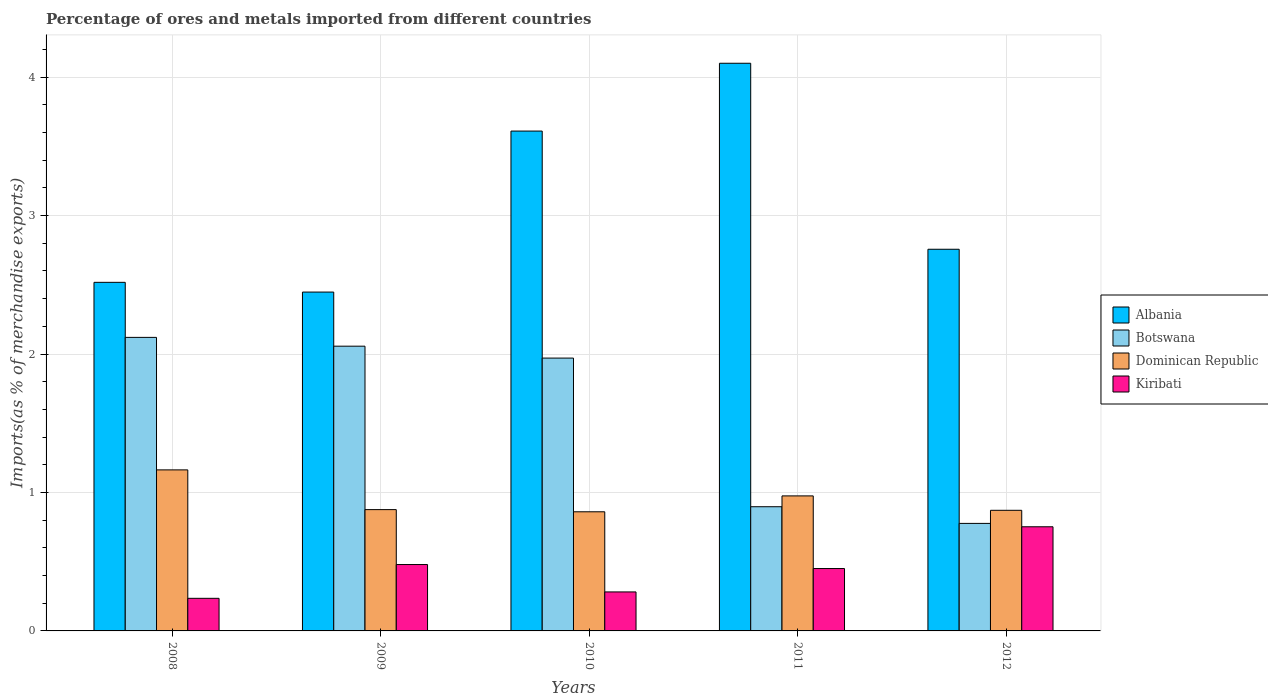How many different coloured bars are there?
Offer a terse response. 4. What is the label of the 4th group of bars from the left?
Provide a short and direct response. 2011. In how many cases, is the number of bars for a given year not equal to the number of legend labels?
Make the answer very short. 0. What is the percentage of imports to different countries in Albania in 2012?
Your answer should be compact. 2.76. Across all years, what is the maximum percentage of imports to different countries in Albania?
Your answer should be very brief. 4.1. Across all years, what is the minimum percentage of imports to different countries in Botswana?
Your answer should be very brief. 0.78. In which year was the percentage of imports to different countries in Botswana maximum?
Offer a terse response. 2008. In which year was the percentage of imports to different countries in Albania minimum?
Your answer should be compact. 2009. What is the total percentage of imports to different countries in Albania in the graph?
Offer a terse response. 15.43. What is the difference between the percentage of imports to different countries in Kiribati in 2009 and that in 2011?
Your answer should be compact. 0.03. What is the difference between the percentage of imports to different countries in Botswana in 2010 and the percentage of imports to different countries in Dominican Republic in 2012?
Ensure brevity in your answer.  1.1. What is the average percentage of imports to different countries in Botswana per year?
Your answer should be compact. 1.56. In the year 2008, what is the difference between the percentage of imports to different countries in Dominican Republic and percentage of imports to different countries in Botswana?
Provide a short and direct response. -0.96. What is the ratio of the percentage of imports to different countries in Albania in 2010 to that in 2011?
Give a very brief answer. 0.88. What is the difference between the highest and the second highest percentage of imports to different countries in Kiribati?
Your answer should be very brief. 0.27. What is the difference between the highest and the lowest percentage of imports to different countries in Albania?
Keep it short and to the point. 1.65. What does the 1st bar from the left in 2011 represents?
Offer a terse response. Albania. What does the 2nd bar from the right in 2012 represents?
Make the answer very short. Dominican Republic. How many bars are there?
Provide a succinct answer. 20. What is the difference between two consecutive major ticks on the Y-axis?
Make the answer very short. 1. Are the values on the major ticks of Y-axis written in scientific E-notation?
Offer a very short reply. No. Does the graph contain any zero values?
Offer a terse response. No. Where does the legend appear in the graph?
Give a very brief answer. Center right. How many legend labels are there?
Keep it short and to the point. 4. What is the title of the graph?
Your response must be concise. Percentage of ores and metals imported from different countries. What is the label or title of the X-axis?
Make the answer very short. Years. What is the label or title of the Y-axis?
Ensure brevity in your answer.  Imports(as % of merchandise exports). What is the Imports(as % of merchandise exports) in Albania in 2008?
Keep it short and to the point. 2.52. What is the Imports(as % of merchandise exports) in Botswana in 2008?
Give a very brief answer. 2.12. What is the Imports(as % of merchandise exports) of Dominican Republic in 2008?
Ensure brevity in your answer.  1.16. What is the Imports(as % of merchandise exports) in Kiribati in 2008?
Provide a short and direct response. 0.24. What is the Imports(as % of merchandise exports) in Albania in 2009?
Ensure brevity in your answer.  2.45. What is the Imports(as % of merchandise exports) of Botswana in 2009?
Offer a very short reply. 2.06. What is the Imports(as % of merchandise exports) of Dominican Republic in 2009?
Provide a succinct answer. 0.88. What is the Imports(as % of merchandise exports) in Kiribati in 2009?
Give a very brief answer. 0.48. What is the Imports(as % of merchandise exports) in Albania in 2010?
Ensure brevity in your answer.  3.61. What is the Imports(as % of merchandise exports) of Botswana in 2010?
Ensure brevity in your answer.  1.97. What is the Imports(as % of merchandise exports) in Dominican Republic in 2010?
Keep it short and to the point. 0.86. What is the Imports(as % of merchandise exports) in Kiribati in 2010?
Offer a very short reply. 0.28. What is the Imports(as % of merchandise exports) of Albania in 2011?
Provide a succinct answer. 4.1. What is the Imports(as % of merchandise exports) of Botswana in 2011?
Offer a terse response. 0.9. What is the Imports(as % of merchandise exports) of Dominican Republic in 2011?
Your answer should be very brief. 0.98. What is the Imports(as % of merchandise exports) of Kiribati in 2011?
Provide a short and direct response. 0.45. What is the Imports(as % of merchandise exports) in Albania in 2012?
Your response must be concise. 2.76. What is the Imports(as % of merchandise exports) in Botswana in 2012?
Provide a succinct answer. 0.78. What is the Imports(as % of merchandise exports) of Dominican Republic in 2012?
Give a very brief answer. 0.87. What is the Imports(as % of merchandise exports) of Kiribati in 2012?
Your answer should be very brief. 0.75. Across all years, what is the maximum Imports(as % of merchandise exports) in Albania?
Give a very brief answer. 4.1. Across all years, what is the maximum Imports(as % of merchandise exports) of Botswana?
Offer a very short reply. 2.12. Across all years, what is the maximum Imports(as % of merchandise exports) of Dominican Republic?
Give a very brief answer. 1.16. Across all years, what is the maximum Imports(as % of merchandise exports) in Kiribati?
Make the answer very short. 0.75. Across all years, what is the minimum Imports(as % of merchandise exports) of Albania?
Make the answer very short. 2.45. Across all years, what is the minimum Imports(as % of merchandise exports) in Botswana?
Offer a terse response. 0.78. Across all years, what is the minimum Imports(as % of merchandise exports) in Dominican Republic?
Provide a short and direct response. 0.86. Across all years, what is the minimum Imports(as % of merchandise exports) in Kiribati?
Ensure brevity in your answer.  0.24. What is the total Imports(as % of merchandise exports) in Albania in the graph?
Keep it short and to the point. 15.43. What is the total Imports(as % of merchandise exports) in Botswana in the graph?
Your answer should be compact. 7.82. What is the total Imports(as % of merchandise exports) of Dominican Republic in the graph?
Your answer should be very brief. 4.75. What is the total Imports(as % of merchandise exports) in Kiribati in the graph?
Offer a terse response. 2.2. What is the difference between the Imports(as % of merchandise exports) of Albania in 2008 and that in 2009?
Your answer should be compact. 0.07. What is the difference between the Imports(as % of merchandise exports) of Botswana in 2008 and that in 2009?
Provide a succinct answer. 0.06. What is the difference between the Imports(as % of merchandise exports) of Dominican Republic in 2008 and that in 2009?
Your response must be concise. 0.29. What is the difference between the Imports(as % of merchandise exports) in Kiribati in 2008 and that in 2009?
Provide a succinct answer. -0.24. What is the difference between the Imports(as % of merchandise exports) of Albania in 2008 and that in 2010?
Your answer should be compact. -1.09. What is the difference between the Imports(as % of merchandise exports) in Botswana in 2008 and that in 2010?
Your answer should be compact. 0.15. What is the difference between the Imports(as % of merchandise exports) in Dominican Republic in 2008 and that in 2010?
Your answer should be compact. 0.3. What is the difference between the Imports(as % of merchandise exports) of Kiribati in 2008 and that in 2010?
Keep it short and to the point. -0.05. What is the difference between the Imports(as % of merchandise exports) of Albania in 2008 and that in 2011?
Give a very brief answer. -1.58. What is the difference between the Imports(as % of merchandise exports) in Botswana in 2008 and that in 2011?
Your answer should be compact. 1.22. What is the difference between the Imports(as % of merchandise exports) in Dominican Republic in 2008 and that in 2011?
Offer a very short reply. 0.19. What is the difference between the Imports(as % of merchandise exports) in Kiribati in 2008 and that in 2011?
Provide a short and direct response. -0.22. What is the difference between the Imports(as % of merchandise exports) of Albania in 2008 and that in 2012?
Your answer should be compact. -0.24. What is the difference between the Imports(as % of merchandise exports) of Botswana in 2008 and that in 2012?
Your response must be concise. 1.34. What is the difference between the Imports(as % of merchandise exports) of Dominican Republic in 2008 and that in 2012?
Give a very brief answer. 0.29. What is the difference between the Imports(as % of merchandise exports) of Kiribati in 2008 and that in 2012?
Make the answer very short. -0.52. What is the difference between the Imports(as % of merchandise exports) of Albania in 2009 and that in 2010?
Make the answer very short. -1.16. What is the difference between the Imports(as % of merchandise exports) in Botswana in 2009 and that in 2010?
Offer a very short reply. 0.09. What is the difference between the Imports(as % of merchandise exports) of Dominican Republic in 2009 and that in 2010?
Your answer should be very brief. 0.02. What is the difference between the Imports(as % of merchandise exports) of Kiribati in 2009 and that in 2010?
Keep it short and to the point. 0.2. What is the difference between the Imports(as % of merchandise exports) of Albania in 2009 and that in 2011?
Give a very brief answer. -1.65. What is the difference between the Imports(as % of merchandise exports) in Botswana in 2009 and that in 2011?
Ensure brevity in your answer.  1.16. What is the difference between the Imports(as % of merchandise exports) of Dominican Republic in 2009 and that in 2011?
Your answer should be compact. -0.1. What is the difference between the Imports(as % of merchandise exports) in Kiribati in 2009 and that in 2011?
Give a very brief answer. 0.03. What is the difference between the Imports(as % of merchandise exports) of Albania in 2009 and that in 2012?
Offer a terse response. -0.31. What is the difference between the Imports(as % of merchandise exports) of Botswana in 2009 and that in 2012?
Provide a succinct answer. 1.28. What is the difference between the Imports(as % of merchandise exports) of Dominican Republic in 2009 and that in 2012?
Your response must be concise. 0. What is the difference between the Imports(as % of merchandise exports) in Kiribati in 2009 and that in 2012?
Make the answer very short. -0.27. What is the difference between the Imports(as % of merchandise exports) of Albania in 2010 and that in 2011?
Your answer should be very brief. -0.49. What is the difference between the Imports(as % of merchandise exports) in Botswana in 2010 and that in 2011?
Your answer should be very brief. 1.07. What is the difference between the Imports(as % of merchandise exports) of Dominican Republic in 2010 and that in 2011?
Keep it short and to the point. -0.11. What is the difference between the Imports(as % of merchandise exports) in Kiribati in 2010 and that in 2011?
Make the answer very short. -0.17. What is the difference between the Imports(as % of merchandise exports) in Albania in 2010 and that in 2012?
Ensure brevity in your answer.  0.85. What is the difference between the Imports(as % of merchandise exports) in Botswana in 2010 and that in 2012?
Your answer should be compact. 1.19. What is the difference between the Imports(as % of merchandise exports) of Dominican Republic in 2010 and that in 2012?
Your answer should be compact. -0.01. What is the difference between the Imports(as % of merchandise exports) of Kiribati in 2010 and that in 2012?
Your response must be concise. -0.47. What is the difference between the Imports(as % of merchandise exports) in Albania in 2011 and that in 2012?
Keep it short and to the point. 1.34. What is the difference between the Imports(as % of merchandise exports) in Botswana in 2011 and that in 2012?
Ensure brevity in your answer.  0.12. What is the difference between the Imports(as % of merchandise exports) of Dominican Republic in 2011 and that in 2012?
Your response must be concise. 0.1. What is the difference between the Imports(as % of merchandise exports) of Kiribati in 2011 and that in 2012?
Your answer should be compact. -0.3. What is the difference between the Imports(as % of merchandise exports) of Albania in 2008 and the Imports(as % of merchandise exports) of Botswana in 2009?
Make the answer very short. 0.46. What is the difference between the Imports(as % of merchandise exports) in Albania in 2008 and the Imports(as % of merchandise exports) in Dominican Republic in 2009?
Ensure brevity in your answer.  1.64. What is the difference between the Imports(as % of merchandise exports) in Albania in 2008 and the Imports(as % of merchandise exports) in Kiribati in 2009?
Give a very brief answer. 2.04. What is the difference between the Imports(as % of merchandise exports) in Botswana in 2008 and the Imports(as % of merchandise exports) in Dominican Republic in 2009?
Your response must be concise. 1.24. What is the difference between the Imports(as % of merchandise exports) of Botswana in 2008 and the Imports(as % of merchandise exports) of Kiribati in 2009?
Your answer should be very brief. 1.64. What is the difference between the Imports(as % of merchandise exports) of Dominican Republic in 2008 and the Imports(as % of merchandise exports) of Kiribati in 2009?
Give a very brief answer. 0.68. What is the difference between the Imports(as % of merchandise exports) of Albania in 2008 and the Imports(as % of merchandise exports) of Botswana in 2010?
Give a very brief answer. 0.55. What is the difference between the Imports(as % of merchandise exports) in Albania in 2008 and the Imports(as % of merchandise exports) in Dominican Republic in 2010?
Offer a very short reply. 1.66. What is the difference between the Imports(as % of merchandise exports) of Albania in 2008 and the Imports(as % of merchandise exports) of Kiribati in 2010?
Keep it short and to the point. 2.24. What is the difference between the Imports(as % of merchandise exports) of Botswana in 2008 and the Imports(as % of merchandise exports) of Dominican Republic in 2010?
Offer a very short reply. 1.26. What is the difference between the Imports(as % of merchandise exports) of Botswana in 2008 and the Imports(as % of merchandise exports) of Kiribati in 2010?
Provide a succinct answer. 1.84. What is the difference between the Imports(as % of merchandise exports) in Dominican Republic in 2008 and the Imports(as % of merchandise exports) in Kiribati in 2010?
Make the answer very short. 0.88. What is the difference between the Imports(as % of merchandise exports) in Albania in 2008 and the Imports(as % of merchandise exports) in Botswana in 2011?
Make the answer very short. 1.62. What is the difference between the Imports(as % of merchandise exports) of Albania in 2008 and the Imports(as % of merchandise exports) of Dominican Republic in 2011?
Give a very brief answer. 1.54. What is the difference between the Imports(as % of merchandise exports) in Albania in 2008 and the Imports(as % of merchandise exports) in Kiribati in 2011?
Ensure brevity in your answer.  2.07. What is the difference between the Imports(as % of merchandise exports) in Botswana in 2008 and the Imports(as % of merchandise exports) in Dominican Republic in 2011?
Offer a very short reply. 1.15. What is the difference between the Imports(as % of merchandise exports) in Botswana in 2008 and the Imports(as % of merchandise exports) in Kiribati in 2011?
Make the answer very short. 1.67. What is the difference between the Imports(as % of merchandise exports) in Dominican Republic in 2008 and the Imports(as % of merchandise exports) in Kiribati in 2011?
Ensure brevity in your answer.  0.71. What is the difference between the Imports(as % of merchandise exports) in Albania in 2008 and the Imports(as % of merchandise exports) in Botswana in 2012?
Make the answer very short. 1.74. What is the difference between the Imports(as % of merchandise exports) of Albania in 2008 and the Imports(as % of merchandise exports) of Dominican Republic in 2012?
Your response must be concise. 1.65. What is the difference between the Imports(as % of merchandise exports) of Albania in 2008 and the Imports(as % of merchandise exports) of Kiribati in 2012?
Provide a succinct answer. 1.77. What is the difference between the Imports(as % of merchandise exports) of Botswana in 2008 and the Imports(as % of merchandise exports) of Dominican Republic in 2012?
Give a very brief answer. 1.25. What is the difference between the Imports(as % of merchandise exports) of Botswana in 2008 and the Imports(as % of merchandise exports) of Kiribati in 2012?
Keep it short and to the point. 1.37. What is the difference between the Imports(as % of merchandise exports) of Dominican Republic in 2008 and the Imports(as % of merchandise exports) of Kiribati in 2012?
Offer a terse response. 0.41. What is the difference between the Imports(as % of merchandise exports) of Albania in 2009 and the Imports(as % of merchandise exports) of Botswana in 2010?
Your answer should be very brief. 0.48. What is the difference between the Imports(as % of merchandise exports) in Albania in 2009 and the Imports(as % of merchandise exports) in Dominican Republic in 2010?
Ensure brevity in your answer.  1.59. What is the difference between the Imports(as % of merchandise exports) of Albania in 2009 and the Imports(as % of merchandise exports) of Kiribati in 2010?
Your response must be concise. 2.17. What is the difference between the Imports(as % of merchandise exports) of Botswana in 2009 and the Imports(as % of merchandise exports) of Dominican Republic in 2010?
Provide a succinct answer. 1.2. What is the difference between the Imports(as % of merchandise exports) in Botswana in 2009 and the Imports(as % of merchandise exports) in Kiribati in 2010?
Your response must be concise. 1.78. What is the difference between the Imports(as % of merchandise exports) in Dominican Republic in 2009 and the Imports(as % of merchandise exports) in Kiribati in 2010?
Ensure brevity in your answer.  0.59. What is the difference between the Imports(as % of merchandise exports) of Albania in 2009 and the Imports(as % of merchandise exports) of Botswana in 2011?
Provide a succinct answer. 1.55. What is the difference between the Imports(as % of merchandise exports) in Albania in 2009 and the Imports(as % of merchandise exports) in Dominican Republic in 2011?
Give a very brief answer. 1.47. What is the difference between the Imports(as % of merchandise exports) of Albania in 2009 and the Imports(as % of merchandise exports) of Kiribati in 2011?
Your answer should be very brief. 2. What is the difference between the Imports(as % of merchandise exports) of Botswana in 2009 and the Imports(as % of merchandise exports) of Dominican Republic in 2011?
Your answer should be compact. 1.08. What is the difference between the Imports(as % of merchandise exports) of Botswana in 2009 and the Imports(as % of merchandise exports) of Kiribati in 2011?
Offer a terse response. 1.61. What is the difference between the Imports(as % of merchandise exports) in Dominican Republic in 2009 and the Imports(as % of merchandise exports) in Kiribati in 2011?
Make the answer very short. 0.43. What is the difference between the Imports(as % of merchandise exports) of Albania in 2009 and the Imports(as % of merchandise exports) of Botswana in 2012?
Provide a succinct answer. 1.67. What is the difference between the Imports(as % of merchandise exports) of Albania in 2009 and the Imports(as % of merchandise exports) of Dominican Republic in 2012?
Provide a short and direct response. 1.58. What is the difference between the Imports(as % of merchandise exports) of Albania in 2009 and the Imports(as % of merchandise exports) of Kiribati in 2012?
Give a very brief answer. 1.7. What is the difference between the Imports(as % of merchandise exports) of Botswana in 2009 and the Imports(as % of merchandise exports) of Dominican Republic in 2012?
Provide a succinct answer. 1.19. What is the difference between the Imports(as % of merchandise exports) in Botswana in 2009 and the Imports(as % of merchandise exports) in Kiribati in 2012?
Provide a short and direct response. 1.3. What is the difference between the Imports(as % of merchandise exports) of Dominican Republic in 2009 and the Imports(as % of merchandise exports) of Kiribati in 2012?
Your answer should be compact. 0.12. What is the difference between the Imports(as % of merchandise exports) in Albania in 2010 and the Imports(as % of merchandise exports) in Botswana in 2011?
Make the answer very short. 2.71. What is the difference between the Imports(as % of merchandise exports) of Albania in 2010 and the Imports(as % of merchandise exports) of Dominican Republic in 2011?
Offer a terse response. 2.64. What is the difference between the Imports(as % of merchandise exports) in Albania in 2010 and the Imports(as % of merchandise exports) in Kiribati in 2011?
Make the answer very short. 3.16. What is the difference between the Imports(as % of merchandise exports) in Botswana in 2010 and the Imports(as % of merchandise exports) in Dominican Republic in 2011?
Your answer should be compact. 1. What is the difference between the Imports(as % of merchandise exports) of Botswana in 2010 and the Imports(as % of merchandise exports) of Kiribati in 2011?
Your answer should be compact. 1.52. What is the difference between the Imports(as % of merchandise exports) in Dominican Republic in 2010 and the Imports(as % of merchandise exports) in Kiribati in 2011?
Ensure brevity in your answer.  0.41. What is the difference between the Imports(as % of merchandise exports) of Albania in 2010 and the Imports(as % of merchandise exports) of Botswana in 2012?
Provide a short and direct response. 2.83. What is the difference between the Imports(as % of merchandise exports) in Albania in 2010 and the Imports(as % of merchandise exports) in Dominican Republic in 2012?
Give a very brief answer. 2.74. What is the difference between the Imports(as % of merchandise exports) in Albania in 2010 and the Imports(as % of merchandise exports) in Kiribati in 2012?
Ensure brevity in your answer.  2.86. What is the difference between the Imports(as % of merchandise exports) in Botswana in 2010 and the Imports(as % of merchandise exports) in Dominican Republic in 2012?
Your response must be concise. 1.1. What is the difference between the Imports(as % of merchandise exports) of Botswana in 2010 and the Imports(as % of merchandise exports) of Kiribati in 2012?
Make the answer very short. 1.22. What is the difference between the Imports(as % of merchandise exports) in Dominican Republic in 2010 and the Imports(as % of merchandise exports) in Kiribati in 2012?
Provide a short and direct response. 0.11. What is the difference between the Imports(as % of merchandise exports) in Albania in 2011 and the Imports(as % of merchandise exports) in Botswana in 2012?
Make the answer very short. 3.32. What is the difference between the Imports(as % of merchandise exports) of Albania in 2011 and the Imports(as % of merchandise exports) of Dominican Republic in 2012?
Your answer should be compact. 3.23. What is the difference between the Imports(as % of merchandise exports) in Albania in 2011 and the Imports(as % of merchandise exports) in Kiribati in 2012?
Provide a short and direct response. 3.35. What is the difference between the Imports(as % of merchandise exports) of Botswana in 2011 and the Imports(as % of merchandise exports) of Dominican Republic in 2012?
Offer a terse response. 0.03. What is the difference between the Imports(as % of merchandise exports) in Botswana in 2011 and the Imports(as % of merchandise exports) in Kiribati in 2012?
Give a very brief answer. 0.14. What is the difference between the Imports(as % of merchandise exports) in Dominican Republic in 2011 and the Imports(as % of merchandise exports) in Kiribati in 2012?
Keep it short and to the point. 0.22. What is the average Imports(as % of merchandise exports) in Albania per year?
Make the answer very short. 3.09. What is the average Imports(as % of merchandise exports) in Botswana per year?
Your answer should be very brief. 1.56. What is the average Imports(as % of merchandise exports) in Dominican Republic per year?
Offer a very short reply. 0.95. What is the average Imports(as % of merchandise exports) of Kiribati per year?
Your answer should be compact. 0.44. In the year 2008, what is the difference between the Imports(as % of merchandise exports) of Albania and Imports(as % of merchandise exports) of Botswana?
Give a very brief answer. 0.4. In the year 2008, what is the difference between the Imports(as % of merchandise exports) in Albania and Imports(as % of merchandise exports) in Dominican Republic?
Your answer should be compact. 1.35. In the year 2008, what is the difference between the Imports(as % of merchandise exports) in Albania and Imports(as % of merchandise exports) in Kiribati?
Provide a succinct answer. 2.28. In the year 2008, what is the difference between the Imports(as % of merchandise exports) of Botswana and Imports(as % of merchandise exports) of Dominican Republic?
Ensure brevity in your answer.  0.96. In the year 2008, what is the difference between the Imports(as % of merchandise exports) of Botswana and Imports(as % of merchandise exports) of Kiribati?
Provide a succinct answer. 1.88. In the year 2008, what is the difference between the Imports(as % of merchandise exports) of Dominican Republic and Imports(as % of merchandise exports) of Kiribati?
Your answer should be very brief. 0.93. In the year 2009, what is the difference between the Imports(as % of merchandise exports) of Albania and Imports(as % of merchandise exports) of Botswana?
Your response must be concise. 0.39. In the year 2009, what is the difference between the Imports(as % of merchandise exports) of Albania and Imports(as % of merchandise exports) of Dominican Republic?
Provide a succinct answer. 1.57. In the year 2009, what is the difference between the Imports(as % of merchandise exports) in Albania and Imports(as % of merchandise exports) in Kiribati?
Give a very brief answer. 1.97. In the year 2009, what is the difference between the Imports(as % of merchandise exports) of Botswana and Imports(as % of merchandise exports) of Dominican Republic?
Your answer should be compact. 1.18. In the year 2009, what is the difference between the Imports(as % of merchandise exports) in Botswana and Imports(as % of merchandise exports) in Kiribati?
Your response must be concise. 1.58. In the year 2009, what is the difference between the Imports(as % of merchandise exports) in Dominican Republic and Imports(as % of merchandise exports) in Kiribati?
Make the answer very short. 0.4. In the year 2010, what is the difference between the Imports(as % of merchandise exports) in Albania and Imports(as % of merchandise exports) in Botswana?
Offer a very short reply. 1.64. In the year 2010, what is the difference between the Imports(as % of merchandise exports) in Albania and Imports(as % of merchandise exports) in Dominican Republic?
Your answer should be very brief. 2.75. In the year 2010, what is the difference between the Imports(as % of merchandise exports) of Albania and Imports(as % of merchandise exports) of Kiribati?
Your response must be concise. 3.33. In the year 2010, what is the difference between the Imports(as % of merchandise exports) in Botswana and Imports(as % of merchandise exports) in Dominican Republic?
Your answer should be compact. 1.11. In the year 2010, what is the difference between the Imports(as % of merchandise exports) of Botswana and Imports(as % of merchandise exports) of Kiribati?
Your response must be concise. 1.69. In the year 2010, what is the difference between the Imports(as % of merchandise exports) of Dominican Republic and Imports(as % of merchandise exports) of Kiribati?
Give a very brief answer. 0.58. In the year 2011, what is the difference between the Imports(as % of merchandise exports) of Albania and Imports(as % of merchandise exports) of Botswana?
Your answer should be compact. 3.2. In the year 2011, what is the difference between the Imports(as % of merchandise exports) in Albania and Imports(as % of merchandise exports) in Dominican Republic?
Offer a terse response. 3.13. In the year 2011, what is the difference between the Imports(as % of merchandise exports) in Albania and Imports(as % of merchandise exports) in Kiribati?
Offer a very short reply. 3.65. In the year 2011, what is the difference between the Imports(as % of merchandise exports) of Botswana and Imports(as % of merchandise exports) of Dominican Republic?
Make the answer very short. -0.08. In the year 2011, what is the difference between the Imports(as % of merchandise exports) of Botswana and Imports(as % of merchandise exports) of Kiribati?
Provide a succinct answer. 0.45. In the year 2011, what is the difference between the Imports(as % of merchandise exports) in Dominican Republic and Imports(as % of merchandise exports) in Kiribati?
Your answer should be very brief. 0.52. In the year 2012, what is the difference between the Imports(as % of merchandise exports) of Albania and Imports(as % of merchandise exports) of Botswana?
Your answer should be compact. 1.98. In the year 2012, what is the difference between the Imports(as % of merchandise exports) in Albania and Imports(as % of merchandise exports) in Dominican Republic?
Your answer should be compact. 1.89. In the year 2012, what is the difference between the Imports(as % of merchandise exports) in Albania and Imports(as % of merchandise exports) in Kiribati?
Offer a terse response. 2. In the year 2012, what is the difference between the Imports(as % of merchandise exports) in Botswana and Imports(as % of merchandise exports) in Dominican Republic?
Offer a terse response. -0.09. In the year 2012, what is the difference between the Imports(as % of merchandise exports) in Botswana and Imports(as % of merchandise exports) in Kiribati?
Ensure brevity in your answer.  0.02. In the year 2012, what is the difference between the Imports(as % of merchandise exports) in Dominican Republic and Imports(as % of merchandise exports) in Kiribati?
Your response must be concise. 0.12. What is the ratio of the Imports(as % of merchandise exports) in Albania in 2008 to that in 2009?
Your answer should be very brief. 1.03. What is the ratio of the Imports(as % of merchandise exports) in Botswana in 2008 to that in 2009?
Your answer should be very brief. 1.03. What is the ratio of the Imports(as % of merchandise exports) in Dominican Republic in 2008 to that in 2009?
Ensure brevity in your answer.  1.33. What is the ratio of the Imports(as % of merchandise exports) of Kiribati in 2008 to that in 2009?
Offer a terse response. 0.49. What is the ratio of the Imports(as % of merchandise exports) in Albania in 2008 to that in 2010?
Offer a very short reply. 0.7. What is the ratio of the Imports(as % of merchandise exports) in Botswana in 2008 to that in 2010?
Make the answer very short. 1.08. What is the ratio of the Imports(as % of merchandise exports) in Dominican Republic in 2008 to that in 2010?
Make the answer very short. 1.35. What is the ratio of the Imports(as % of merchandise exports) in Kiribati in 2008 to that in 2010?
Offer a terse response. 0.84. What is the ratio of the Imports(as % of merchandise exports) in Albania in 2008 to that in 2011?
Your answer should be very brief. 0.61. What is the ratio of the Imports(as % of merchandise exports) of Botswana in 2008 to that in 2011?
Provide a succinct answer. 2.36. What is the ratio of the Imports(as % of merchandise exports) of Dominican Republic in 2008 to that in 2011?
Make the answer very short. 1.19. What is the ratio of the Imports(as % of merchandise exports) of Kiribati in 2008 to that in 2011?
Offer a very short reply. 0.52. What is the ratio of the Imports(as % of merchandise exports) of Albania in 2008 to that in 2012?
Provide a succinct answer. 0.91. What is the ratio of the Imports(as % of merchandise exports) in Botswana in 2008 to that in 2012?
Make the answer very short. 2.73. What is the ratio of the Imports(as % of merchandise exports) of Dominican Republic in 2008 to that in 2012?
Keep it short and to the point. 1.34. What is the ratio of the Imports(as % of merchandise exports) of Kiribati in 2008 to that in 2012?
Provide a short and direct response. 0.31. What is the ratio of the Imports(as % of merchandise exports) of Albania in 2009 to that in 2010?
Offer a terse response. 0.68. What is the ratio of the Imports(as % of merchandise exports) in Botswana in 2009 to that in 2010?
Your answer should be compact. 1.04. What is the ratio of the Imports(as % of merchandise exports) of Dominican Republic in 2009 to that in 2010?
Keep it short and to the point. 1.02. What is the ratio of the Imports(as % of merchandise exports) of Kiribati in 2009 to that in 2010?
Your answer should be very brief. 1.7. What is the ratio of the Imports(as % of merchandise exports) in Albania in 2009 to that in 2011?
Provide a succinct answer. 0.6. What is the ratio of the Imports(as % of merchandise exports) in Botswana in 2009 to that in 2011?
Keep it short and to the point. 2.29. What is the ratio of the Imports(as % of merchandise exports) of Dominican Republic in 2009 to that in 2011?
Provide a succinct answer. 0.9. What is the ratio of the Imports(as % of merchandise exports) in Kiribati in 2009 to that in 2011?
Give a very brief answer. 1.06. What is the ratio of the Imports(as % of merchandise exports) in Albania in 2009 to that in 2012?
Your answer should be compact. 0.89. What is the ratio of the Imports(as % of merchandise exports) of Botswana in 2009 to that in 2012?
Offer a terse response. 2.65. What is the ratio of the Imports(as % of merchandise exports) of Kiribati in 2009 to that in 2012?
Offer a terse response. 0.64. What is the ratio of the Imports(as % of merchandise exports) in Albania in 2010 to that in 2011?
Provide a succinct answer. 0.88. What is the ratio of the Imports(as % of merchandise exports) in Botswana in 2010 to that in 2011?
Provide a short and direct response. 2.2. What is the ratio of the Imports(as % of merchandise exports) in Dominican Republic in 2010 to that in 2011?
Your answer should be very brief. 0.88. What is the ratio of the Imports(as % of merchandise exports) in Kiribati in 2010 to that in 2011?
Offer a very short reply. 0.63. What is the ratio of the Imports(as % of merchandise exports) of Albania in 2010 to that in 2012?
Your response must be concise. 1.31. What is the ratio of the Imports(as % of merchandise exports) in Botswana in 2010 to that in 2012?
Your response must be concise. 2.54. What is the ratio of the Imports(as % of merchandise exports) in Dominican Republic in 2010 to that in 2012?
Your answer should be compact. 0.99. What is the ratio of the Imports(as % of merchandise exports) of Kiribati in 2010 to that in 2012?
Make the answer very short. 0.37. What is the ratio of the Imports(as % of merchandise exports) of Albania in 2011 to that in 2012?
Your answer should be very brief. 1.49. What is the ratio of the Imports(as % of merchandise exports) in Botswana in 2011 to that in 2012?
Your response must be concise. 1.15. What is the ratio of the Imports(as % of merchandise exports) in Dominican Republic in 2011 to that in 2012?
Your answer should be very brief. 1.12. What is the ratio of the Imports(as % of merchandise exports) in Kiribati in 2011 to that in 2012?
Your answer should be compact. 0.6. What is the difference between the highest and the second highest Imports(as % of merchandise exports) in Albania?
Ensure brevity in your answer.  0.49. What is the difference between the highest and the second highest Imports(as % of merchandise exports) of Botswana?
Keep it short and to the point. 0.06. What is the difference between the highest and the second highest Imports(as % of merchandise exports) in Dominican Republic?
Provide a short and direct response. 0.19. What is the difference between the highest and the second highest Imports(as % of merchandise exports) in Kiribati?
Make the answer very short. 0.27. What is the difference between the highest and the lowest Imports(as % of merchandise exports) in Albania?
Ensure brevity in your answer.  1.65. What is the difference between the highest and the lowest Imports(as % of merchandise exports) in Botswana?
Give a very brief answer. 1.34. What is the difference between the highest and the lowest Imports(as % of merchandise exports) of Dominican Republic?
Ensure brevity in your answer.  0.3. What is the difference between the highest and the lowest Imports(as % of merchandise exports) of Kiribati?
Provide a short and direct response. 0.52. 